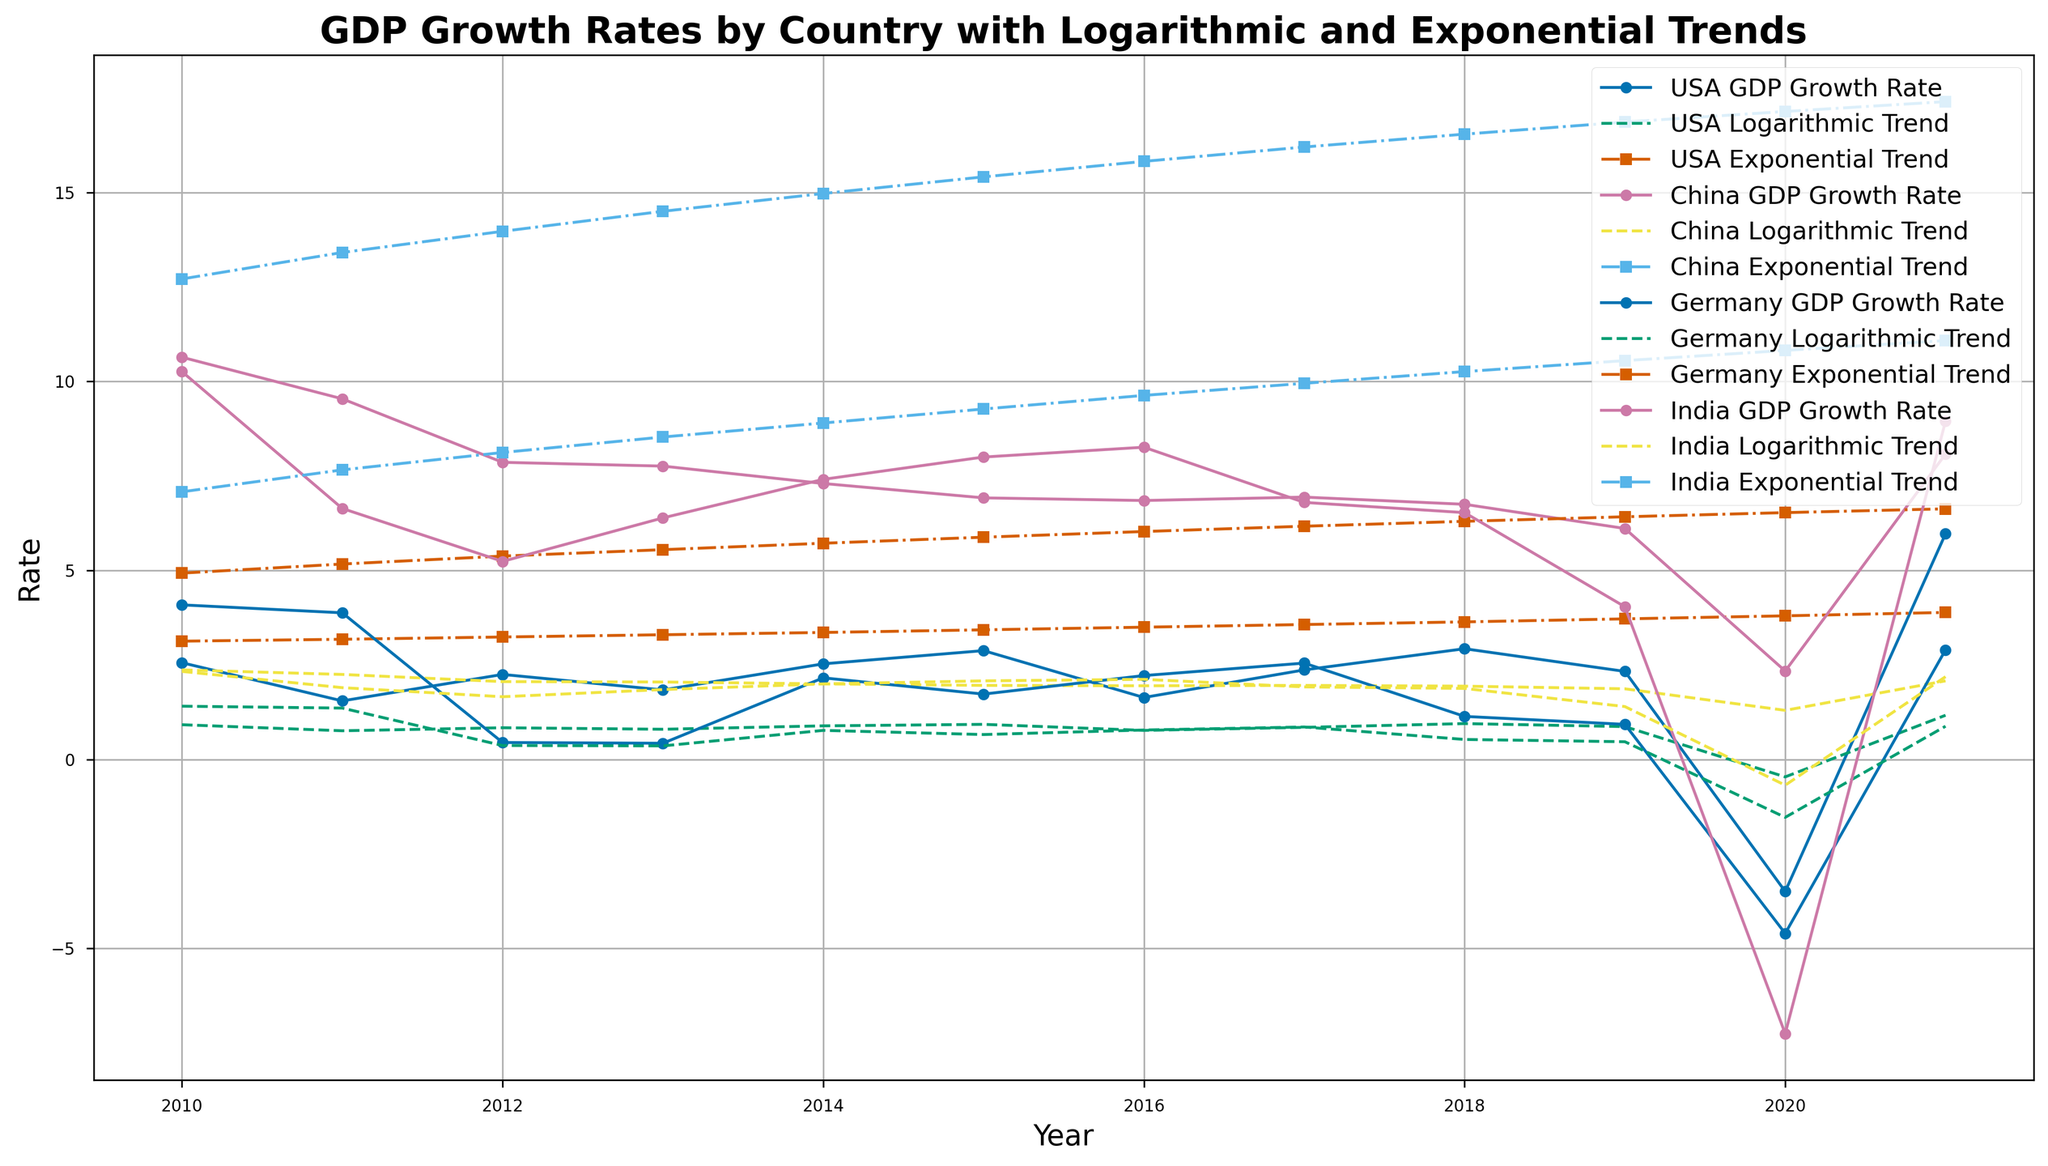Which country's GDP growth rate was the highest in 2021? By looking at the plot, we can determine which country's GDP growth rate reached the highest point in 2021. China, the USA, Germany, and India are included. By tracing the data points for each country in 2021, we can see that India had the highest GDP growth rate.
Answer: India How did the USA's GDP growth rate in 2020 compare to India's growth rate in 2020? Referring to the plot, we can visually compare the respective data points for the USA and India in 2020. We see the USA had a significant drop to -3.49, while India dropped even further to -7.25.
Answer: India's growth rate was lower In which year did China’s GDP growth rate fall to around 2.34%, and was this represented more closely by the exponential or logarithmic trend? By examining the trend lines and associated GDP growth rate for China, we see that in 2020 China’s GDP growth rate fell to about 2.34%. This drop is closer to the logarithmic trend (1.30) than the exponential trend (17.14).
Answer: 2020, logarithmic trend What is the average GDP growth rate of Germany between 2015 and 2019? Look at the GDP growth rate values for Germany in 2015 through 2019: 1.73, 2.22, 2.55, 1.14, and 0.93. Summing these values and then dividing by 5 will give the average: (1.73 + 2.22 + 2.55 + 1.14 + 0.93)/5 = 1.714.
Answer: 1.71 Comparing the logarithmic trends for the USA and India, which country had a higher trend in 2016? By examining the plot for the logarithmic trend lines in 2016, the USA had a logarithmic trend value of 0.77 while India had 2.12. Hence, India had the higher logarithmic trend in 2016.
Answer: India Which countries exhibited a negative GDP growth rate in 2020, and how do their subsequent 2021 growth rates compare? By looking at the data points in the plot for 2020, both the USA (-3.49) and Germany (-4.60) had negative GDP growth rates. In 2021, both countries show recovery with the USA at 5.97 and Germany at 2.90. Hence, the USA had a higher subsequent recovery growth rate.
Answer: USA and Germany, USA had higher growth in 2021 Did India's GDP growth rate in 2013 exceed both its logarithmic and exponential trends for that year? Checking the data points for India in 2013, the GDP growth rate was 6.39, while its logarithmic trend was 1.85 and exponential trend was 8.53. Since 6.39 is greater than the logarithmic trend but less than the exponential trend, India's GDP growth rate exceeded its logarithmic trend but not its exponential trend.
Answer: Yes (logarithmic), No (exponential) Which country’s GDP growth rate showed the steepest decline from 2019 to 2020, and by how much? Looking at the changes in data points from 2019 to 2020 for each country, the USA, China, Germany, and India show respective differences. India had a decline from 4.04 in 2019 to -7.25 in 2020, a difference of 11.29, which is the steepest.
Answer: India, 11.29 